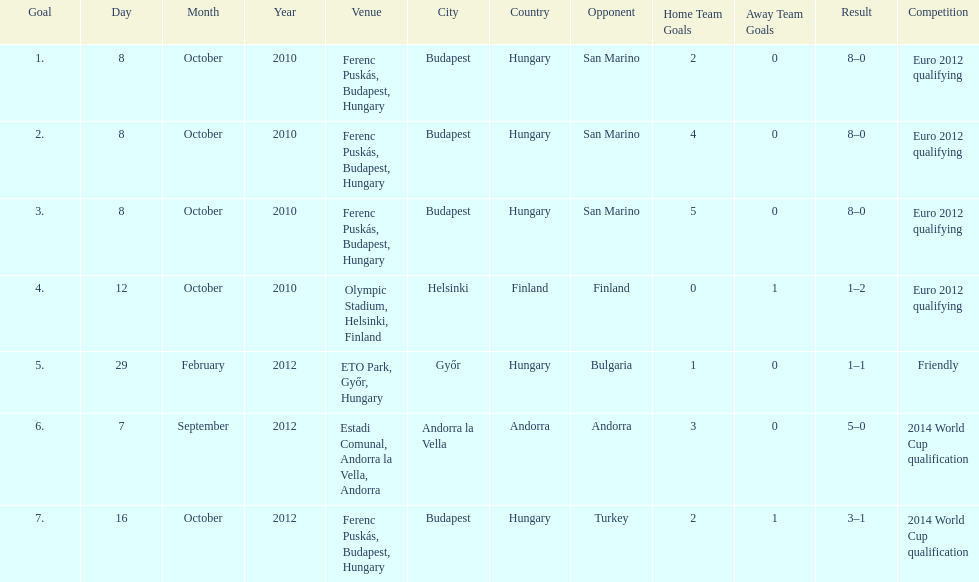How many games did he score but his team lost? 1. 